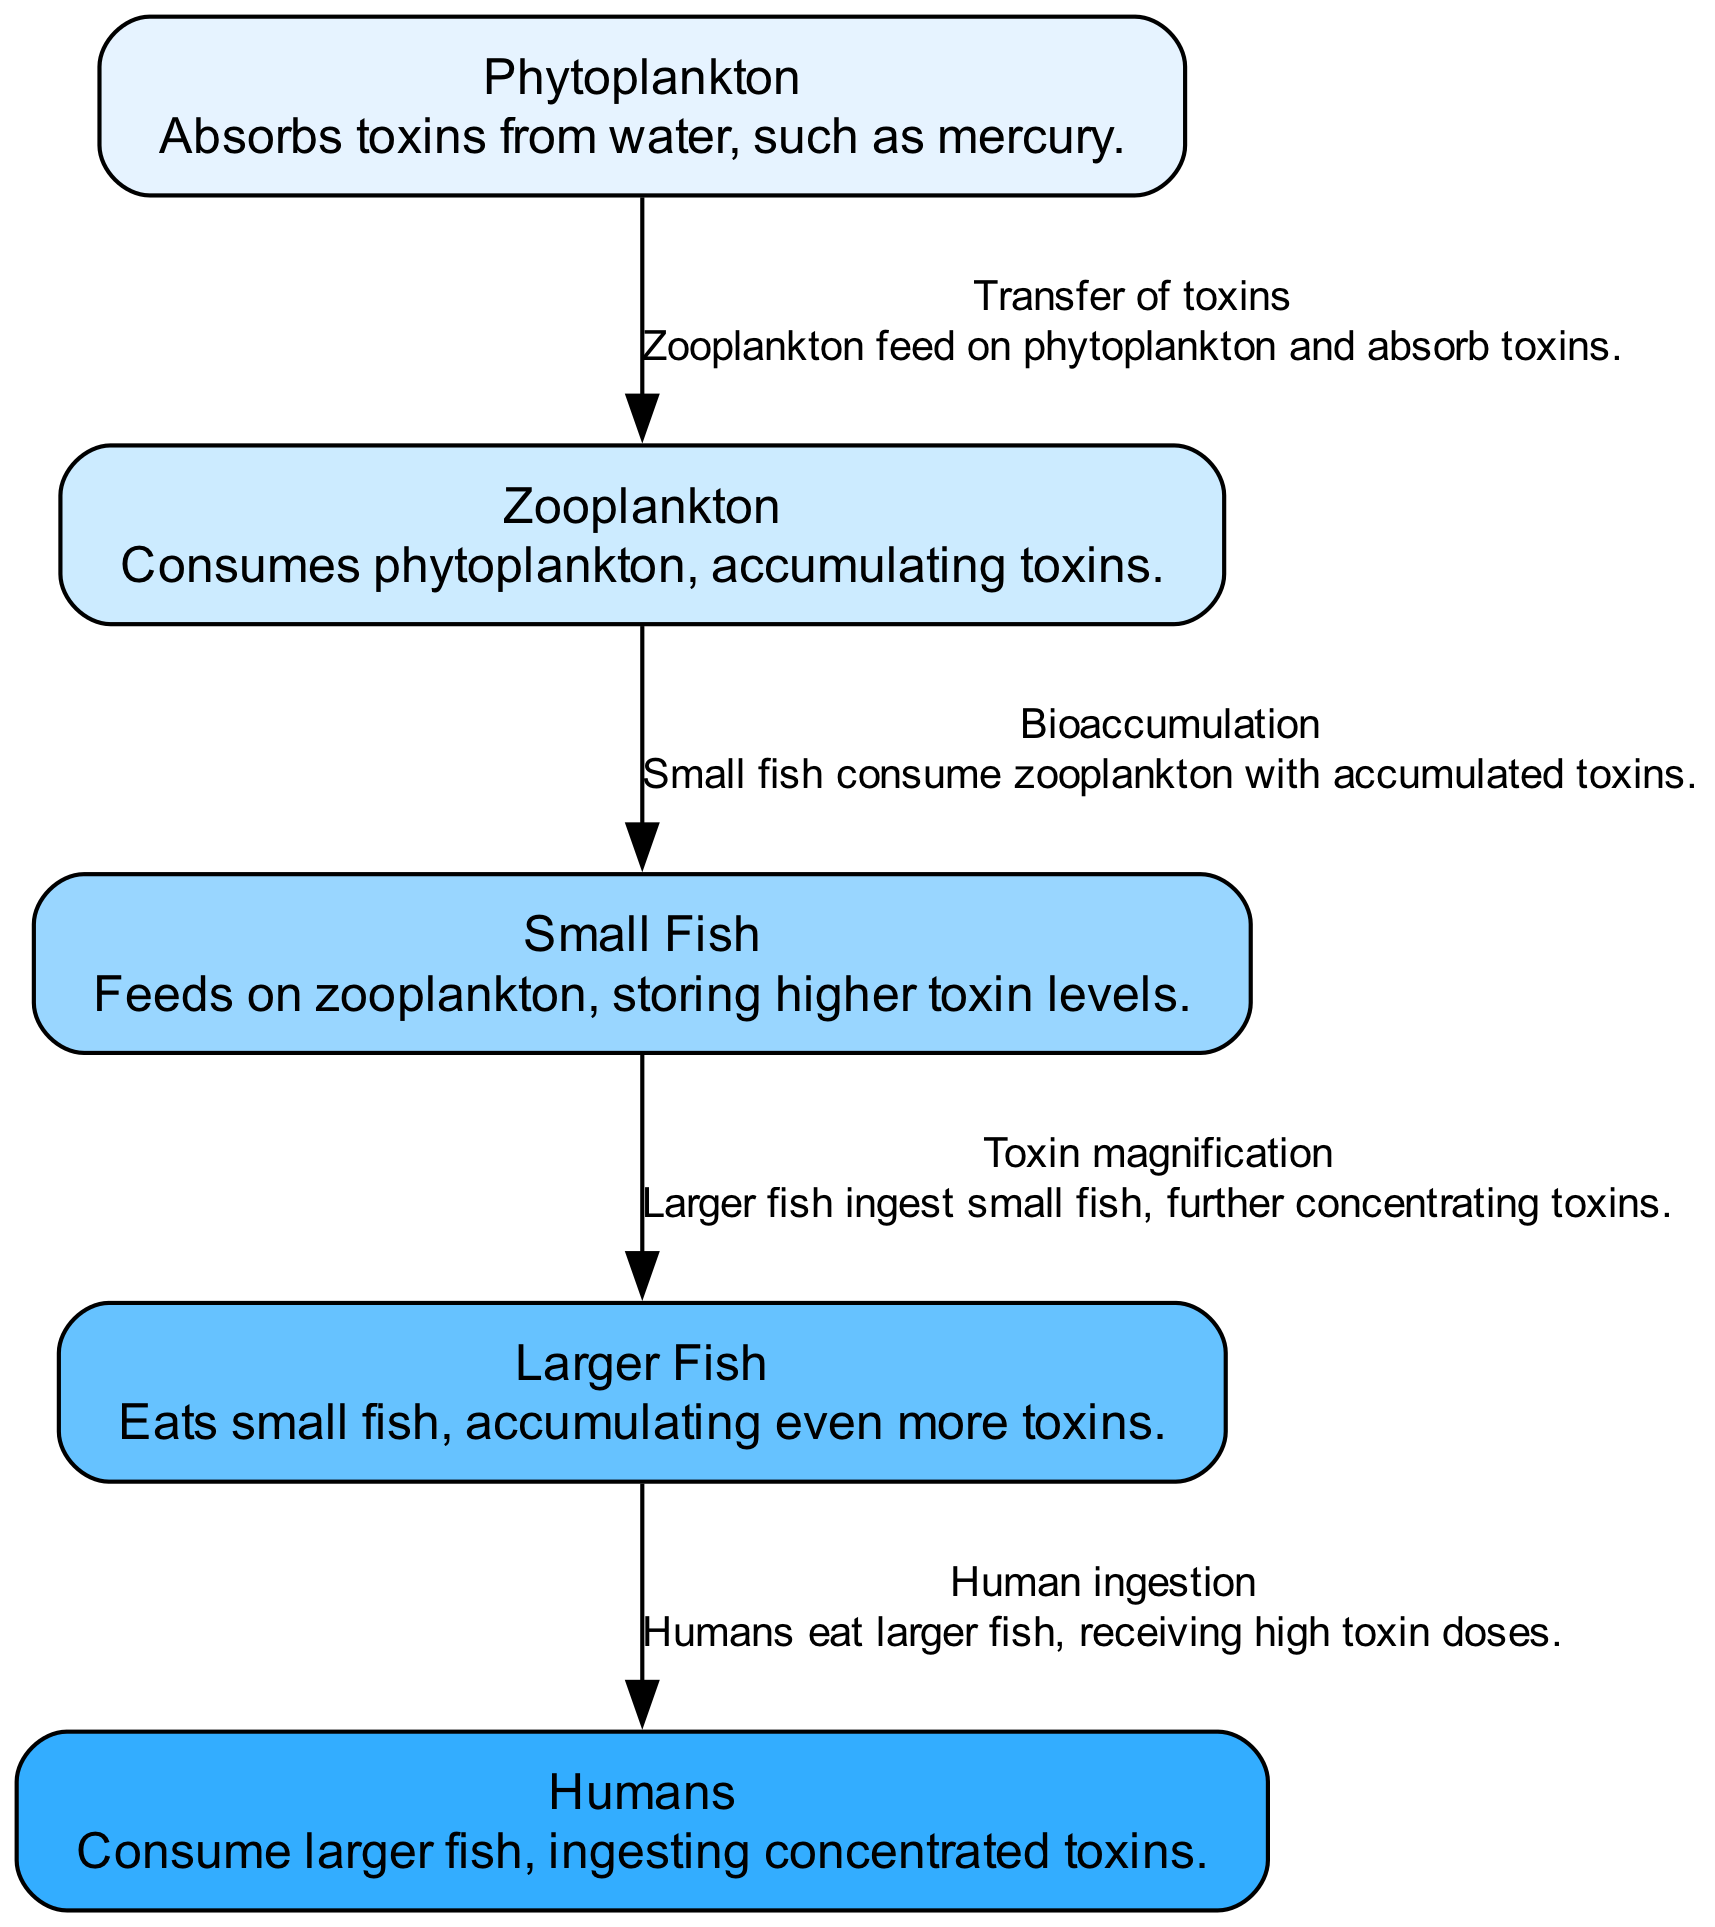What is the first organism in the food chain? The diagram lists "Phytoplankton" as the first node, indicating it is the primary producer in the food chain.
Answer: Phytoplankton How many trophic levels are there in the diagram? There are five nodes in the diagram: Phytoplankton, Zooplankton, Small Fish, Larger Fish, and Humans, each representing a distinct trophic level.
Answer: Five What type of relationship exists between Zooplankton and Small Fish? The edge description indicates a "Bioaccumulation" relationship, meaning that Small Fish consume Zooplankton, which contains accumulated toxins.
Answer: Bioaccumulation Which organism experiences the highest level of toxin concentration? The final node, "Humans," eat Larger Fish, which have accumulated toxins from Small Fish and Zooplankton, making them the most impacted by toxins.
Answer: Humans What describes the connection between Larger Fish and Humans? The relationship is characterized as "Human ingestion," signifying that humans directly consume larger fish, affecting their toxin levels.
Answer: Human ingestion What is the last organism to absorb toxins in this food chain? From the flow of the diagram, it is evident that "Humans" are the last in the chain to ingest toxins from larger fish.
Answer: Humans How do toxins accumulate in Zooplankton? The description states that Zooplankton consume phytoplankton, which absorbs toxins from water, leading to toxin accumulation in Zooplankton.
Answer: By consuming phytoplankton What is the color scheme employed in the nodes of the diagram? The nodes are styled with a gradient color palette ranging from light blue to darker blue, visually distinguishing each trophic level.
Answer: Gradient blue colors Which organism is described as storing higher toxin levels than others? The node for "Small Fish" specifically states that they store higher levels of toxins, having consumed zooplankton which already contains toxins.
Answer: Small Fish 